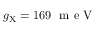<formula> <loc_0><loc_0><loc_500><loc_500>g _ { X } = 1 6 9 m e V</formula> 